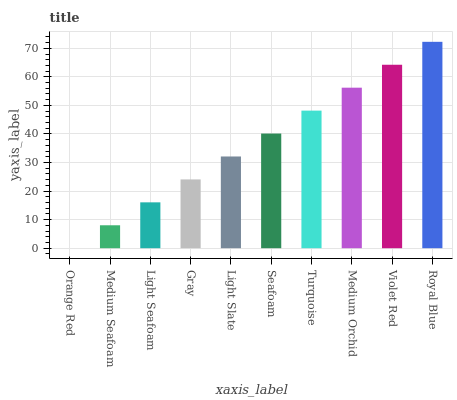Is Orange Red the minimum?
Answer yes or no. Yes. Is Royal Blue the maximum?
Answer yes or no. Yes. Is Medium Seafoam the minimum?
Answer yes or no. No. Is Medium Seafoam the maximum?
Answer yes or no. No. Is Medium Seafoam greater than Orange Red?
Answer yes or no. Yes. Is Orange Red less than Medium Seafoam?
Answer yes or no. Yes. Is Orange Red greater than Medium Seafoam?
Answer yes or no. No. Is Medium Seafoam less than Orange Red?
Answer yes or no. No. Is Seafoam the high median?
Answer yes or no. Yes. Is Light Slate the low median?
Answer yes or no. Yes. Is Orange Red the high median?
Answer yes or no. No. Is Light Seafoam the low median?
Answer yes or no. No. 